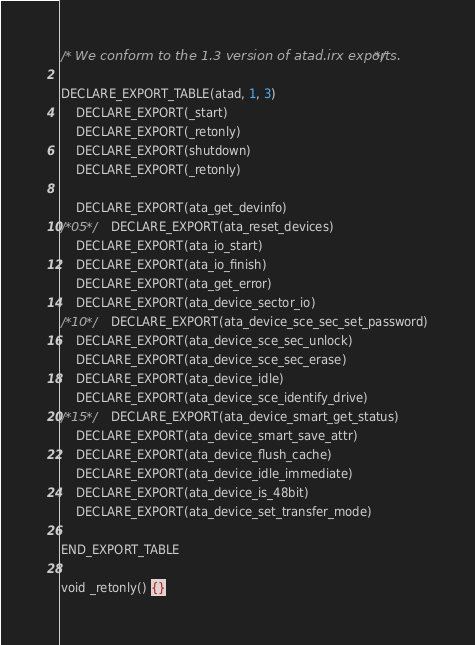<code> <loc_0><loc_0><loc_500><loc_500><_SQL_>/* We conform to the 1.3 version of atad.irx exports.  */

DECLARE_EXPORT_TABLE(atad, 1, 3)
	DECLARE_EXPORT(_start)
	DECLARE_EXPORT(_retonly)
	DECLARE_EXPORT(shutdown)
	DECLARE_EXPORT(_retonly)

	DECLARE_EXPORT(ata_get_devinfo)
/*05*/	DECLARE_EXPORT(ata_reset_devices)
	DECLARE_EXPORT(ata_io_start)
	DECLARE_EXPORT(ata_io_finish)
	DECLARE_EXPORT(ata_get_error)
	DECLARE_EXPORT(ata_device_sector_io)
/*10*/	DECLARE_EXPORT(ata_device_sce_sec_set_password)
	DECLARE_EXPORT(ata_device_sce_sec_unlock)
	DECLARE_EXPORT(ata_device_sce_sec_erase)
	DECLARE_EXPORT(ata_device_idle)
	DECLARE_EXPORT(ata_device_sce_identify_drive)
/*15*/	DECLARE_EXPORT(ata_device_smart_get_status)
	DECLARE_EXPORT(ata_device_smart_save_attr)
	DECLARE_EXPORT(ata_device_flush_cache)
	DECLARE_EXPORT(ata_device_idle_immediate)
	DECLARE_EXPORT(ata_device_is_48bit)
	DECLARE_EXPORT(ata_device_set_transfer_mode)

END_EXPORT_TABLE

void _retonly() {}
</code> 